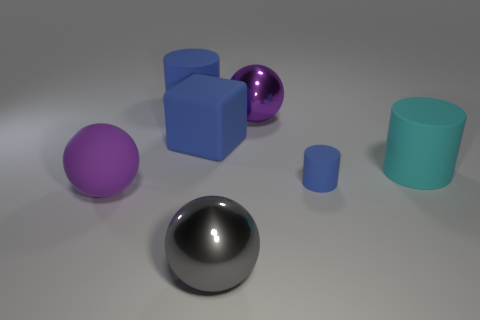How big is the cylinder that is in front of the cube and left of the cyan cylinder?
Your answer should be compact. Small. What is the color of the big rubber object that is the same shape as the large purple shiny object?
Provide a succinct answer. Purple. Is the big blue object that is in front of the big blue cylinder made of the same material as the sphere behind the large cyan matte object?
Make the answer very short. No. Does the large matte block have the same color as the matte cylinder left of the small blue object?
Your answer should be compact. Yes. The large object that is the same color as the big rubber ball is what shape?
Your answer should be very brief. Sphere. What size is the purple metal object that is the same shape as the gray shiny thing?
Your answer should be very brief. Large. What number of large cylinders have the same material as the cyan thing?
Give a very brief answer. 1. There is a small object that is made of the same material as the big cube; what color is it?
Provide a short and direct response. Blue. Is the shape of the large cyan thing the same as the purple metallic object?
Make the answer very short. No. There is a big blue rubber thing to the right of the matte cylinder that is behind the large cyan rubber cylinder; are there any things to the left of it?
Keep it short and to the point. Yes. 